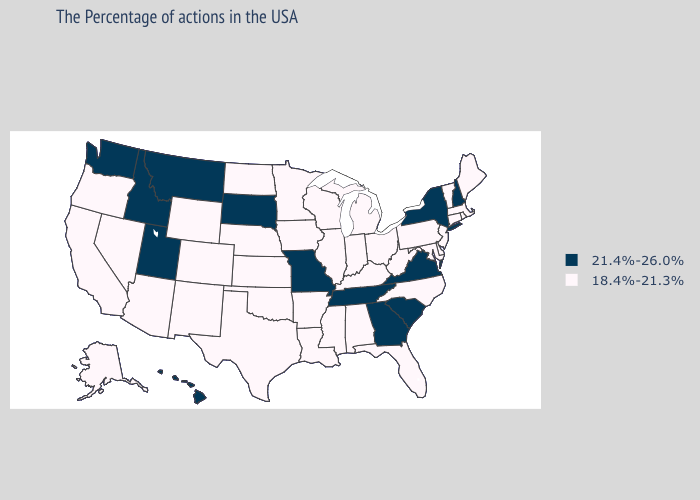Name the states that have a value in the range 21.4%-26.0%?
Be succinct. New Hampshire, New York, Virginia, South Carolina, Georgia, Tennessee, Missouri, South Dakota, Utah, Montana, Idaho, Washington, Hawaii. What is the lowest value in states that border North Dakota?
Write a very short answer. 18.4%-21.3%. Does New Mexico have a lower value than Georgia?
Be succinct. Yes. Does Missouri have the highest value in the USA?
Concise answer only. Yes. What is the highest value in the Northeast ?
Give a very brief answer. 21.4%-26.0%. Does New Mexico have the same value as Michigan?
Quick response, please. Yes. What is the lowest value in states that border North Carolina?
Short answer required. 21.4%-26.0%. Name the states that have a value in the range 18.4%-21.3%?
Quick response, please. Maine, Massachusetts, Rhode Island, Vermont, Connecticut, New Jersey, Delaware, Maryland, Pennsylvania, North Carolina, West Virginia, Ohio, Florida, Michigan, Kentucky, Indiana, Alabama, Wisconsin, Illinois, Mississippi, Louisiana, Arkansas, Minnesota, Iowa, Kansas, Nebraska, Oklahoma, Texas, North Dakota, Wyoming, Colorado, New Mexico, Arizona, Nevada, California, Oregon, Alaska. Does Alabama have the highest value in the USA?
Give a very brief answer. No. Does South Dakota have the lowest value in the MidWest?
Be succinct. No. What is the highest value in the South ?
Keep it brief. 21.4%-26.0%. Name the states that have a value in the range 21.4%-26.0%?
Quick response, please. New Hampshire, New York, Virginia, South Carolina, Georgia, Tennessee, Missouri, South Dakota, Utah, Montana, Idaho, Washington, Hawaii. What is the value of Michigan?
Be succinct. 18.4%-21.3%. Name the states that have a value in the range 18.4%-21.3%?
Answer briefly. Maine, Massachusetts, Rhode Island, Vermont, Connecticut, New Jersey, Delaware, Maryland, Pennsylvania, North Carolina, West Virginia, Ohio, Florida, Michigan, Kentucky, Indiana, Alabama, Wisconsin, Illinois, Mississippi, Louisiana, Arkansas, Minnesota, Iowa, Kansas, Nebraska, Oklahoma, Texas, North Dakota, Wyoming, Colorado, New Mexico, Arizona, Nevada, California, Oregon, Alaska. 